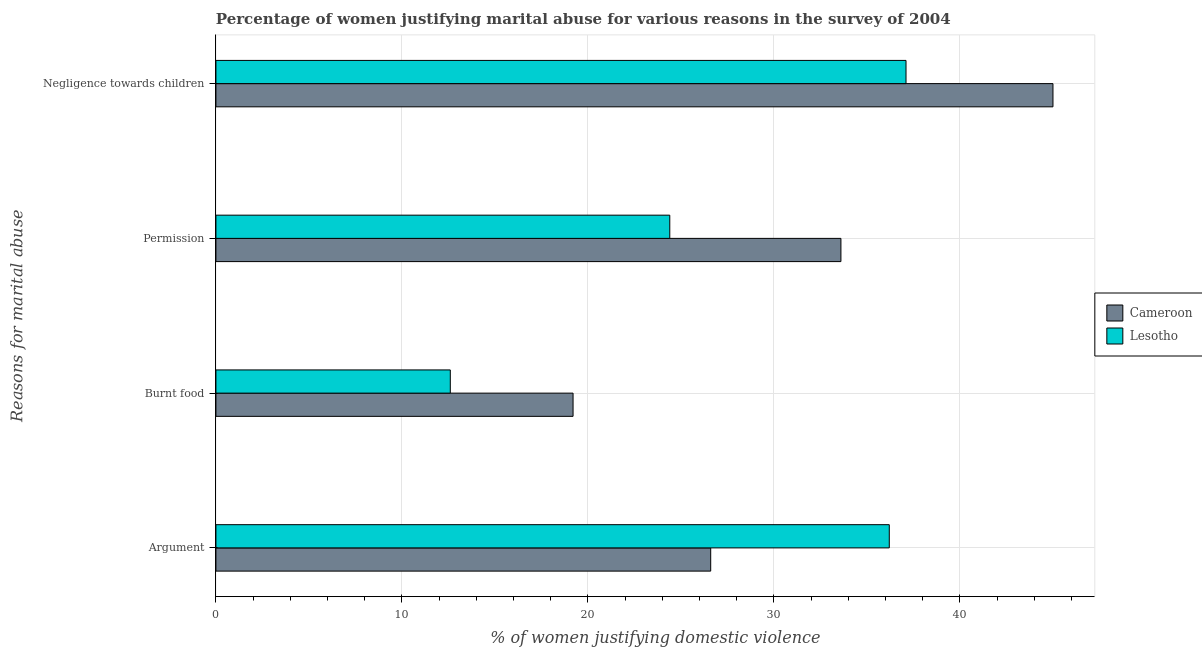Are the number of bars per tick equal to the number of legend labels?
Give a very brief answer. Yes. Are the number of bars on each tick of the Y-axis equal?
Offer a very short reply. Yes. How many bars are there on the 4th tick from the top?
Your response must be concise. 2. What is the label of the 4th group of bars from the top?
Provide a succinct answer. Argument. Across all countries, what is the minimum percentage of women justifying abuse in the case of an argument?
Keep it short and to the point. 26.6. In which country was the percentage of women justifying abuse for showing negligence towards children maximum?
Keep it short and to the point. Cameroon. In which country was the percentage of women justifying abuse for showing negligence towards children minimum?
Make the answer very short. Lesotho. What is the difference between the percentage of women justifying abuse in the case of an argument in Lesotho and that in Cameroon?
Make the answer very short. 9.6. What is the difference between the percentage of women justifying abuse for going without permission in Cameroon and the percentage of women justifying abuse in the case of an argument in Lesotho?
Provide a short and direct response. -2.6. What is the average percentage of women justifying abuse for burning food per country?
Ensure brevity in your answer.  15.9. What is the difference between the percentage of women justifying abuse for going without permission and percentage of women justifying abuse for burning food in Cameroon?
Your response must be concise. 14.4. What is the ratio of the percentage of women justifying abuse for going without permission in Lesotho to that in Cameroon?
Keep it short and to the point. 0.73. Is the percentage of women justifying abuse for showing negligence towards children in Lesotho less than that in Cameroon?
Make the answer very short. Yes. What is the difference between the highest and the second highest percentage of women justifying abuse for going without permission?
Your response must be concise. 9.2. What is the difference between the highest and the lowest percentage of women justifying abuse for showing negligence towards children?
Ensure brevity in your answer.  7.9. In how many countries, is the percentage of women justifying abuse for going without permission greater than the average percentage of women justifying abuse for going without permission taken over all countries?
Give a very brief answer. 1. Is the sum of the percentage of women justifying abuse for showing negligence towards children in Lesotho and Cameroon greater than the maximum percentage of women justifying abuse for burning food across all countries?
Provide a succinct answer. Yes. What does the 2nd bar from the top in Argument represents?
Ensure brevity in your answer.  Cameroon. What does the 2nd bar from the bottom in Permission represents?
Your answer should be very brief. Lesotho. Is it the case that in every country, the sum of the percentage of women justifying abuse in the case of an argument and percentage of women justifying abuse for burning food is greater than the percentage of women justifying abuse for going without permission?
Ensure brevity in your answer.  Yes. How many bars are there?
Provide a short and direct response. 8. Are the values on the major ticks of X-axis written in scientific E-notation?
Keep it short and to the point. No. Does the graph contain any zero values?
Keep it short and to the point. No. Where does the legend appear in the graph?
Provide a succinct answer. Center right. How many legend labels are there?
Your answer should be compact. 2. What is the title of the graph?
Give a very brief answer. Percentage of women justifying marital abuse for various reasons in the survey of 2004. Does "Central Europe" appear as one of the legend labels in the graph?
Offer a very short reply. No. What is the label or title of the X-axis?
Give a very brief answer. % of women justifying domestic violence. What is the label or title of the Y-axis?
Your answer should be compact. Reasons for marital abuse. What is the % of women justifying domestic violence in Cameroon in Argument?
Give a very brief answer. 26.6. What is the % of women justifying domestic violence in Lesotho in Argument?
Offer a terse response. 36.2. What is the % of women justifying domestic violence of Cameroon in Permission?
Your answer should be very brief. 33.6. What is the % of women justifying domestic violence in Lesotho in Permission?
Offer a terse response. 24.4. What is the % of women justifying domestic violence in Cameroon in Negligence towards children?
Your answer should be very brief. 45. What is the % of women justifying domestic violence in Lesotho in Negligence towards children?
Keep it short and to the point. 37.1. Across all Reasons for marital abuse, what is the maximum % of women justifying domestic violence of Cameroon?
Offer a terse response. 45. Across all Reasons for marital abuse, what is the maximum % of women justifying domestic violence in Lesotho?
Give a very brief answer. 37.1. Across all Reasons for marital abuse, what is the minimum % of women justifying domestic violence in Lesotho?
Your answer should be very brief. 12.6. What is the total % of women justifying domestic violence in Cameroon in the graph?
Your answer should be very brief. 124.4. What is the total % of women justifying domestic violence of Lesotho in the graph?
Ensure brevity in your answer.  110.3. What is the difference between the % of women justifying domestic violence in Cameroon in Argument and that in Burnt food?
Your answer should be compact. 7.4. What is the difference between the % of women justifying domestic violence of Lesotho in Argument and that in Burnt food?
Keep it short and to the point. 23.6. What is the difference between the % of women justifying domestic violence in Cameroon in Argument and that in Negligence towards children?
Keep it short and to the point. -18.4. What is the difference between the % of women justifying domestic violence of Lesotho in Argument and that in Negligence towards children?
Your answer should be compact. -0.9. What is the difference between the % of women justifying domestic violence of Cameroon in Burnt food and that in Permission?
Offer a very short reply. -14.4. What is the difference between the % of women justifying domestic violence of Lesotho in Burnt food and that in Permission?
Make the answer very short. -11.8. What is the difference between the % of women justifying domestic violence of Cameroon in Burnt food and that in Negligence towards children?
Your answer should be very brief. -25.8. What is the difference between the % of women justifying domestic violence in Lesotho in Burnt food and that in Negligence towards children?
Your answer should be compact. -24.5. What is the difference between the % of women justifying domestic violence in Cameroon in Permission and that in Negligence towards children?
Keep it short and to the point. -11.4. What is the difference between the % of women justifying domestic violence of Lesotho in Permission and that in Negligence towards children?
Keep it short and to the point. -12.7. What is the difference between the % of women justifying domestic violence in Cameroon in Argument and the % of women justifying domestic violence in Lesotho in Burnt food?
Offer a terse response. 14. What is the difference between the % of women justifying domestic violence of Cameroon in Burnt food and the % of women justifying domestic violence of Lesotho in Permission?
Offer a terse response. -5.2. What is the difference between the % of women justifying domestic violence of Cameroon in Burnt food and the % of women justifying domestic violence of Lesotho in Negligence towards children?
Offer a terse response. -17.9. What is the difference between the % of women justifying domestic violence of Cameroon in Permission and the % of women justifying domestic violence of Lesotho in Negligence towards children?
Your answer should be compact. -3.5. What is the average % of women justifying domestic violence in Cameroon per Reasons for marital abuse?
Your answer should be compact. 31.1. What is the average % of women justifying domestic violence in Lesotho per Reasons for marital abuse?
Ensure brevity in your answer.  27.57. What is the difference between the % of women justifying domestic violence of Cameroon and % of women justifying domestic violence of Lesotho in Argument?
Make the answer very short. -9.6. What is the difference between the % of women justifying domestic violence in Cameroon and % of women justifying domestic violence in Lesotho in Negligence towards children?
Offer a terse response. 7.9. What is the ratio of the % of women justifying domestic violence of Cameroon in Argument to that in Burnt food?
Give a very brief answer. 1.39. What is the ratio of the % of women justifying domestic violence of Lesotho in Argument to that in Burnt food?
Ensure brevity in your answer.  2.87. What is the ratio of the % of women justifying domestic violence in Cameroon in Argument to that in Permission?
Keep it short and to the point. 0.79. What is the ratio of the % of women justifying domestic violence in Lesotho in Argument to that in Permission?
Ensure brevity in your answer.  1.48. What is the ratio of the % of women justifying domestic violence in Cameroon in Argument to that in Negligence towards children?
Keep it short and to the point. 0.59. What is the ratio of the % of women justifying domestic violence in Lesotho in Argument to that in Negligence towards children?
Keep it short and to the point. 0.98. What is the ratio of the % of women justifying domestic violence of Cameroon in Burnt food to that in Permission?
Keep it short and to the point. 0.57. What is the ratio of the % of women justifying domestic violence of Lesotho in Burnt food to that in Permission?
Give a very brief answer. 0.52. What is the ratio of the % of women justifying domestic violence in Cameroon in Burnt food to that in Negligence towards children?
Ensure brevity in your answer.  0.43. What is the ratio of the % of women justifying domestic violence of Lesotho in Burnt food to that in Negligence towards children?
Offer a very short reply. 0.34. What is the ratio of the % of women justifying domestic violence of Cameroon in Permission to that in Negligence towards children?
Ensure brevity in your answer.  0.75. What is the ratio of the % of women justifying domestic violence in Lesotho in Permission to that in Negligence towards children?
Your response must be concise. 0.66. What is the difference between the highest and the second highest % of women justifying domestic violence in Lesotho?
Ensure brevity in your answer.  0.9. What is the difference between the highest and the lowest % of women justifying domestic violence in Cameroon?
Your response must be concise. 25.8. What is the difference between the highest and the lowest % of women justifying domestic violence of Lesotho?
Give a very brief answer. 24.5. 